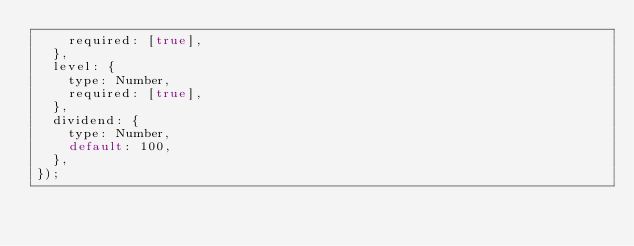<code> <loc_0><loc_0><loc_500><loc_500><_JavaScript_>    required: [true],
  },
  level: {
    type: Number,
    required: [true],
  },
  dividend: {
    type: Number,
    default: 100,
  },
});
</code> 